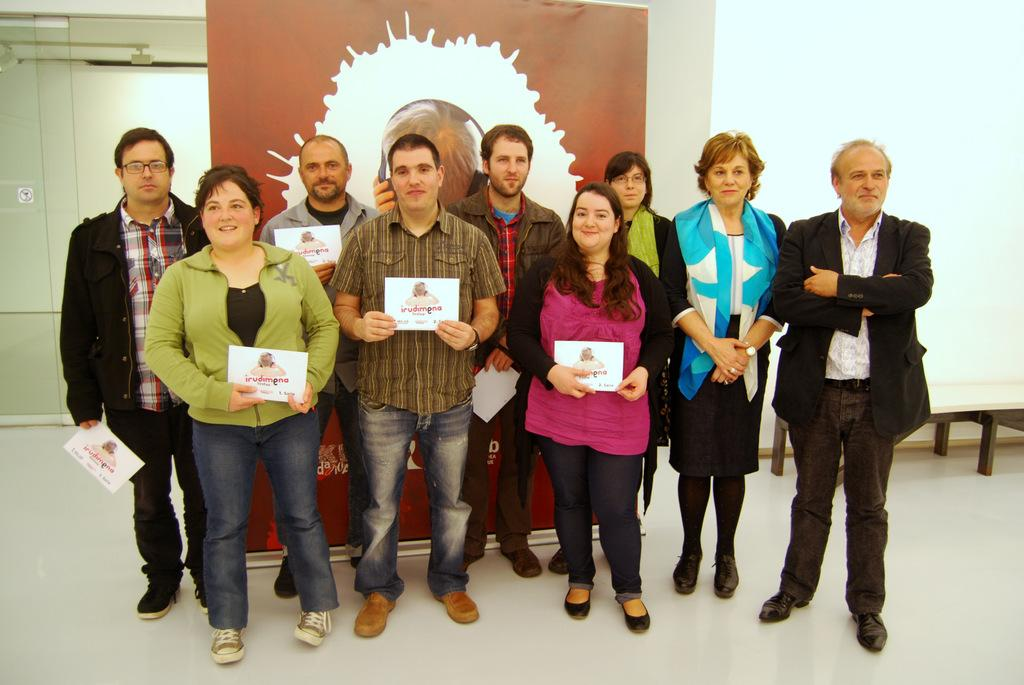What are the people in the image doing? The people in the image are standing and holding cards in their hands. What might the cards represent? The cards could represent a game or activity that the people are participating in. What can be seen in the background of the image? There is a banner visible in the background of the image. What type of creature is pulling the banner in the image? There is no creature present in the image, and the banner is not being pulled by anything. 